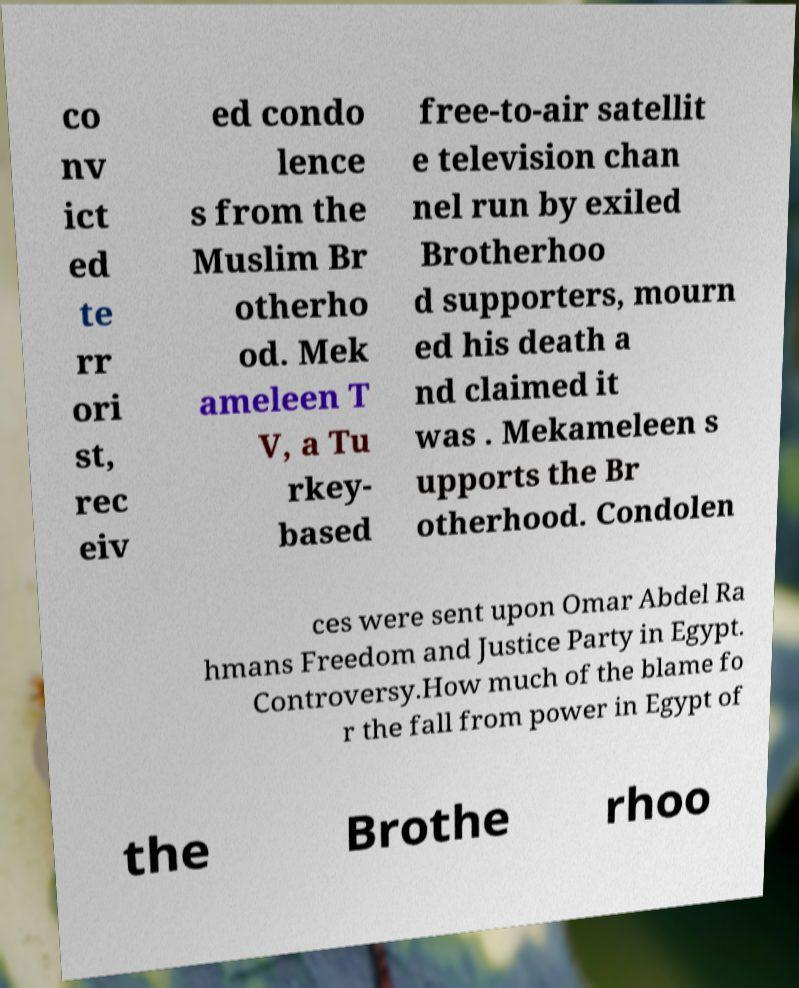For documentation purposes, I need the text within this image transcribed. Could you provide that? co nv ict ed te rr ori st, rec eiv ed condo lence s from the Muslim Br otherho od. Mek ameleen T V, a Tu rkey- based free-to-air satellit e television chan nel run by exiled Brotherhoo d supporters, mourn ed his death a nd claimed it was . Mekameleen s upports the Br otherhood. Condolen ces were sent upon Omar Abdel Ra hmans Freedom and Justice Party in Egypt. Controversy.How much of the blame fo r the fall from power in Egypt of the Brothe rhoo 